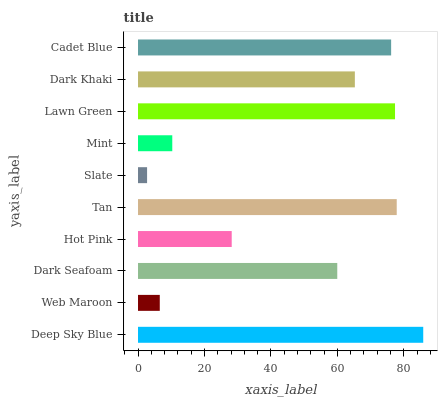Is Slate the minimum?
Answer yes or no. Yes. Is Deep Sky Blue the maximum?
Answer yes or no. Yes. Is Web Maroon the minimum?
Answer yes or no. No. Is Web Maroon the maximum?
Answer yes or no. No. Is Deep Sky Blue greater than Web Maroon?
Answer yes or no. Yes. Is Web Maroon less than Deep Sky Blue?
Answer yes or no. Yes. Is Web Maroon greater than Deep Sky Blue?
Answer yes or no. No. Is Deep Sky Blue less than Web Maroon?
Answer yes or no. No. Is Dark Khaki the high median?
Answer yes or no. Yes. Is Dark Seafoam the low median?
Answer yes or no. Yes. Is Lawn Green the high median?
Answer yes or no. No. Is Slate the low median?
Answer yes or no. No. 